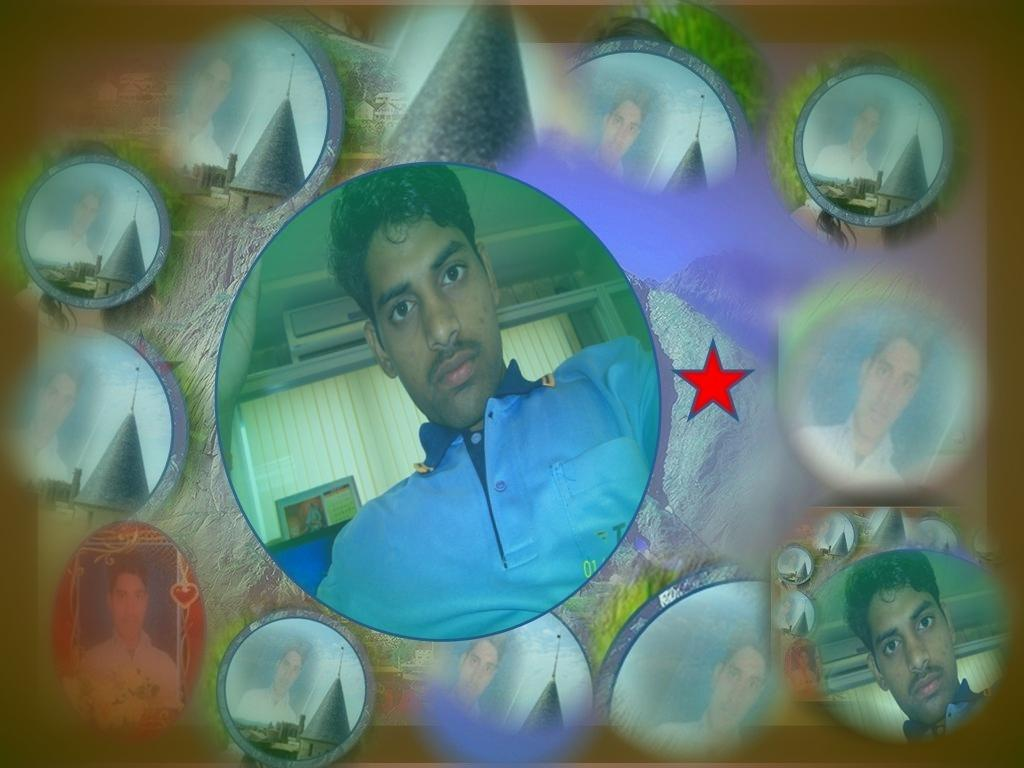What is the main subject of the image? There is a person in the middle of the image. Are there any other people visible in the image? Yes, there are other pictures of a person in the background of the image. What type of pump is being used by the person in the image? There is no pump visible in the image; the main subject is a person in the middle, and there are other pictures of a person in the background. 